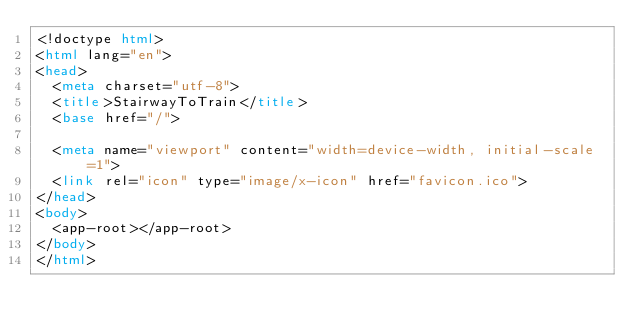Convert code to text. <code><loc_0><loc_0><loc_500><loc_500><_HTML_><!doctype html>
<html lang="en">
<head>
  <meta charset="utf-8">
  <title>StairwayToTrain</title>
  <base href="/">

  <meta name="viewport" content="width=device-width, initial-scale=1">
  <link rel="icon" type="image/x-icon" href="favicon.ico">
</head>
<body>
  <app-root></app-root>
</body>
</html>
</code> 